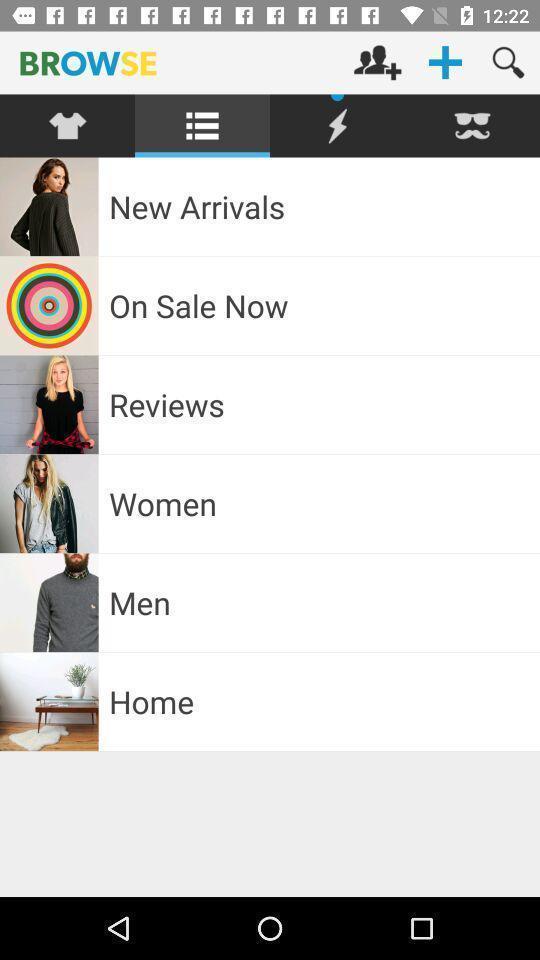Describe the key features of this screenshot. Various types of menu showing in shopping application. 